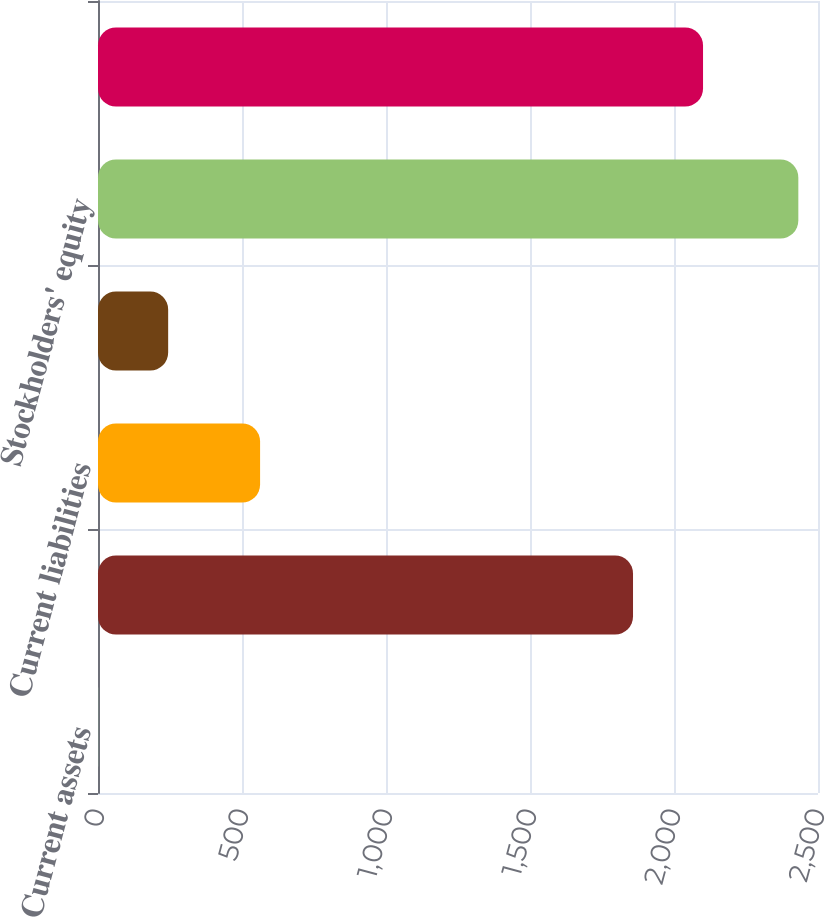Convert chart to OTSL. <chart><loc_0><loc_0><loc_500><loc_500><bar_chart><fcel>Current assets<fcel>Total assets<fcel>Current liabilities<fcel>Other liabilities<fcel>Stockholders' equity<fcel>Total liabilities and equity<nl><fcel>0.5<fcel>1857.7<fcel>562.8<fcel>243.62<fcel>2431.7<fcel>2100.82<nl></chart> 